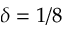<formula> <loc_0><loc_0><loc_500><loc_500>\delta = 1 / 8</formula> 